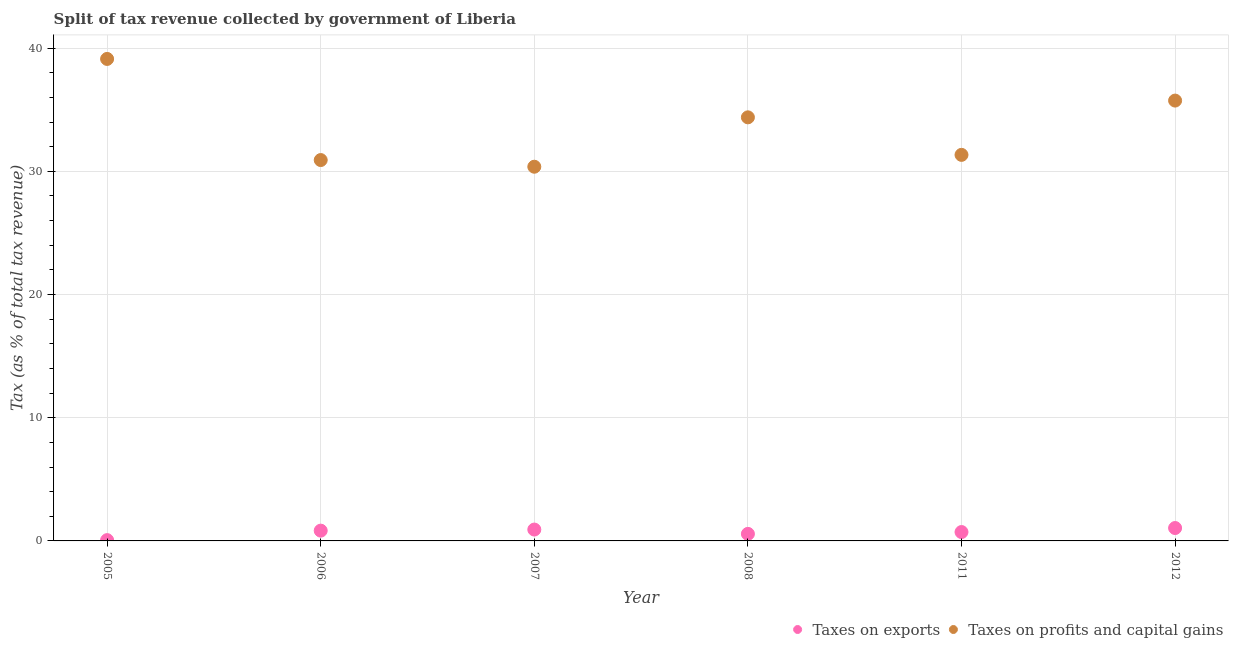What is the percentage of revenue obtained from taxes on exports in 2006?
Offer a terse response. 0.83. Across all years, what is the maximum percentage of revenue obtained from taxes on profits and capital gains?
Your answer should be very brief. 39.13. Across all years, what is the minimum percentage of revenue obtained from taxes on profits and capital gains?
Provide a short and direct response. 30.38. In which year was the percentage of revenue obtained from taxes on exports minimum?
Offer a terse response. 2005. What is the total percentage of revenue obtained from taxes on exports in the graph?
Offer a terse response. 4.16. What is the difference between the percentage of revenue obtained from taxes on profits and capital gains in 2005 and that in 2007?
Ensure brevity in your answer.  8.75. What is the difference between the percentage of revenue obtained from taxes on exports in 2007 and the percentage of revenue obtained from taxes on profits and capital gains in 2012?
Your answer should be compact. -34.82. What is the average percentage of revenue obtained from taxes on profits and capital gains per year?
Give a very brief answer. 33.65. In the year 2006, what is the difference between the percentage of revenue obtained from taxes on exports and percentage of revenue obtained from taxes on profits and capital gains?
Keep it short and to the point. -30.08. In how many years, is the percentage of revenue obtained from taxes on exports greater than 26 %?
Your answer should be compact. 0. What is the ratio of the percentage of revenue obtained from taxes on profits and capital gains in 2008 to that in 2011?
Your answer should be compact. 1.1. Is the percentage of revenue obtained from taxes on profits and capital gains in 2007 less than that in 2011?
Your response must be concise. Yes. Is the difference between the percentage of revenue obtained from taxes on exports in 2008 and 2011 greater than the difference between the percentage of revenue obtained from taxes on profits and capital gains in 2008 and 2011?
Your response must be concise. No. What is the difference between the highest and the second highest percentage of revenue obtained from taxes on profits and capital gains?
Keep it short and to the point. 3.38. What is the difference between the highest and the lowest percentage of revenue obtained from taxes on exports?
Ensure brevity in your answer.  0.98. Is the sum of the percentage of revenue obtained from taxes on exports in 2006 and 2008 greater than the maximum percentage of revenue obtained from taxes on profits and capital gains across all years?
Give a very brief answer. No. Does the percentage of revenue obtained from taxes on profits and capital gains monotonically increase over the years?
Ensure brevity in your answer.  No. Is the percentage of revenue obtained from taxes on profits and capital gains strictly greater than the percentage of revenue obtained from taxes on exports over the years?
Offer a terse response. Yes. What is the difference between two consecutive major ticks on the Y-axis?
Offer a very short reply. 10. Where does the legend appear in the graph?
Ensure brevity in your answer.  Bottom right. What is the title of the graph?
Give a very brief answer. Split of tax revenue collected by government of Liberia. Does "Taxes on exports" appear as one of the legend labels in the graph?
Make the answer very short. Yes. What is the label or title of the Y-axis?
Give a very brief answer. Tax (as % of total tax revenue). What is the Tax (as % of total tax revenue) in Taxes on exports in 2005?
Make the answer very short. 0.06. What is the Tax (as % of total tax revenue) of Taxes on profits and capital gains in 2005?
Your response must be concise. 39.13. What is the Tax (as % of total tax revenue) in Taxes on exports in 2006?
Your answer should be compact. 0.83. What is the Tax (as % of total tax revenue) in Taxes on profits and capital gains in 2006?
Keep it short and to the point. 30.92. What is the Tax (as % of total tax revenue) in Taxes on exports in 2007?
Give a very brief answer. 0.92. What is the Tax (as % of total tax revenue) of Taxes on profits and capital gains in 2007?
Keep it short and to the point. 30.38. What is the Tax (as % of total tax revenue) of Taxes on exports in 2008?
Your answer should be very brief. 0.57. What is the Tax (as % of total tax revenue) of Taxes on profits and capital gains in 2008?
Offer a terse response. 34.38. What is the Tax (as % of total tax revenue) of Taxes on exports in 2011?
Your response must be concise. 0.72. What is the Tax (as % of total tax revenue) in Taxes on profits and capital gains in 2011?
Keep it short and to the point. 31.34. What is the Tax (as % of total tax revenue) in Taxes on exports in 2012?
Provide a short and direct response. 1.05. What is the Tax (as % of total tax revenue) of Taxes on profits and capital gains in 2012?
Your answer should be very brief. 35.74. Across all years, what is the maximum Tax (as % of total tax revenue) of Taxes on exports?
Make the answer very short. 1.05. Across all years, what is the maximum Tax (as % of total tax revenue) in Taxes on profits and capital gains?
Ensure brevity in your answer.  39.13. Across all years, what is the minimum Tax (as % of total tax revenue) of Taxes on exports?
Provide a short and direct response. 0.06. Across all years, what is the minimum Tax (as % of total tax revenue) in Taxes on profits and capital gains?
Your answer should be compact. 30.38. What is the total Tax (as % of total tax revenue) of Taxes on exports in the graph?
Provide a short and direct response. 4.16. What is the total Tax (as % of total tax revenue) of Taxes on profits and capital gains in the graph?
Your response must be concise. 201.89. What is the difference between the Tax (as % of total tax revenue) in Taxes on exports in 2005 and that in 2006?
Make the answer very short. -0.77. What is the difference between the Tax (as % of total tax revenue) of Taxes on profits and capital gains in 2005 and that in 2006?
Provide a succinct answer. 8.21. What is the difference between the Tax (as % of total tax revenue) in Taxes on exports in 2005 and that in 2007?
Provide a succinct answer. -0.86. What is the difference between the Tax (as % of total tax revenue) in Taxes on profits and capital gains in 2005 and that in 2007?
Ensure brevity in your answer.  8.75. What is the difference between the Tax (as % of total tax revenue) of Taxes on exports in 2005 and that in 2008?
Offer a very short reply. -0.51. What is the difference between the Tax (as % of total tax revenue) in Taxes on profits and capital gains in 2005 and that in 2008?
Keep it short and to the point. 4.74. What is the difference between the Tax (as % of total tax revenue) in Taxes on exports in 2005 and that in 2011?
Keep it short and to the point. -0.66. What is the difference between the Tax (as % of total tax revenue) of Taxes on profits and capital gains in 2005 and that in 2011?
Ensure brevity in your answer.  7.79. What is the difference between the Tax (as % of total tax revenue) of Taxes on exports in 2005 and that in 2012?
Offer a very short reply. -0.98. What is the difference between the Tax (as % of total tax revenue) in Taxes on profits and capital gains in 2005 and that in 2012?
Offer a very short reply. 3.38. What is the difference between the Tax (as % of total tax revenue) in Taxes on exports in 2006 and that in 2007?
Your answer should be very brief. -0.09. What is the difference between the Tax (as % of total tax revenue) of Taxes on profits and capital gains in 2006 and that in 2007?
Provide a short and direct response. 0.54. What is the difference between the Tax (as % of total tax revenue) of Taxes on exports in 2006 and that in 2008?
Offer a very short reply. 0.26. What is the difference between the Tax (as % of total tax revenue) of Taxes on profits and capital gains in 2006 and that in 2008?
Your answer should be very brief. -3.47. What is the difference between the Tax (as % of total tax revenue) of Taxes on exports in 2006 and that in 2011?
Keep it short and to the point. 0.11. What is the difference between the Tax (as % of total tax revenue) in Taxes on profits and capital gains in 2006 and that in 2011?
Provide a succinct answer. -0.42. What is the difference between the Tax (as % of total tax revenue) in Taxes on exports in 2006 and that in 2012?
Make the answer very short. -0.21. What is the difference between the Tax (as % of total tax revenue) of Taxes on profits and capital gains in 2006 and that in 2012?
Your response must be concise. -4.83. What is the difference between the Tax (as % of total tax revenue) in Taxes on exports in 2007 and that in 2008?
Make the answer very short. 0.35. What is the difference between the Tax (as % of total tax revenue) in Taxes on profits and capital gains in 2007 and that in 2008?
Your response must be concise. -4.01. What is the difference between the Tax (as % of total tax revenue) in Taxes on exports in 2007 and that in 2011?
Your response must be concise. 0.2. What is the difference between the Tax (as % of total tax revenue) of Taxes on profits and capital gains in 2007 and that in 2011?
Keep it short and to the point. -0.96. What is the difference between the Tax (as % of total tax revenue) of Taxes on exports in 2007 and that in 2012?
Give a very brief answer. -0.12. What is the difference between the Tax (as % of total tax revenue) in Taxes on profits and capital gains in 2007 and that in 2012?
Offer a terse response. -5.37. What is the difference between the Tax (as % of total tax revenue) in Taxes on exports in 2008 and that in 2011?
Ensure brevity in your answer.  -0.15. What is the difference between the Tax (as % of total tax revenue) in Taxes on profits and capital gains in 2008 and that in 2011?
Provide a succinct answer. 3.05. What is the difference between the Tax (as % of total tax revenue) of Taxes on exports in 2008 and that in 2012?
Offer a terse response. -0.47. What is the difference between the Tax (as % of total tax revenue) of Taxes on profits and capital gains in 2008 and that in 2012?
Offer a very short reply. -1.36. What is the difference between the Tax (as % of total tax revenue) of Taxes on exports in 2011 and that in 2012?
Offer a terse response. -0.33. What is the difference between the Tax (as % of total tax revenue) of Taxes on profits and capital gains in 2011 and that in 2012?
Make the answer very short. -4.41. What is the difference between the Tax (as % of total tax revenue) of Taxes on exports in 2005 and the Tax (as % of total tax revenue) of Taxes on profits and capital gains in 2006?
Ensure brevity in your answer.  -30.85. What is the difference between the Tax (as % of total tax revenue) of Taxes on exports in 2005 and the Tax (as % of total tax revenue) of Taxes on profits and capital gains in 2007?
Offer a very short reply. -30.31. What is the difference between the Tax (as % of total tax revenue) of Taxes on exports in 2005 and the Tax (as % of total tax revenue) of Taxes on profits and capital gains in 2008?
Provide a succinct answer. -34.32. What is the difference between the Tax (as % of total tax revenue) in Taxes on exports in 2005 and the Tax (as % of total tax revenue) in Taxes on profits and capital gains in 2011?
Your answer should be very brief. -31.27. What is the difference between the Tax (as % of total tax revenue) in Taxes on exports in 2005 and the Tax (as % of total tax revenue) in Taxes on profits and capital gains in 2012?
Your response must be concise. -35.68. What is the difference between the Tax (as % of total tax revenue) of Taxes on exports in 2006 and the Tax (as % of total tax revenue) of Taxes on profits and capital gains in 2007?
Provide a short and direct response. -29.54. What is the difference between the Tax (as % of total tax revenue) in Taxes on exports in 2006 and the Tax (as % of total tax revenue) in Taxes on profits and capital gains in 2008?
Your answer should be very brief. -33.55. What is the difference between the Tax (as % of total tax revenue) of Taxes on exports in 2006 and the Tax (as % of total tax revenue) of Taxes on profits and capital gains in 2011?
Keep it short and to the point. -30.5. What is the difference between the Tax (as % of total tax revenue) in Taxes on exports in 2006 and the Tax (as % of total tax revenue) in Taxes on profits and capital gains in 2012?
Offer a very short reply. -34.91. What is the difference between the Tax (as % of total tax revenue) in Taxes on exports in 2007 and the Tax (as % of total tax revenue) in Taxes on profits and capital gains in 2008?
Provide a succinct answer. -33.46. What is the difference between the Tax (as % of total tax revenue) in Taxes on exports in 2007 and the Tax (as % of total tax revenue) in Taxes on profits and capital gains in 2011?
Your answer should be very brief. -30.42. What is the difference between the Tax (as % of total tax revenue) in Taxes on exports in 2007 and the Tax (as % of total tax revenue) in Taxes on profits and capital gains in 2012?
Offer a terse response. -34.82. What is the difference between the Tax (as % of total tax revenue) of Taxes on exports in 2008 and the Tax (as % of total tax revenue) of Taxes on profits and capital gains in 2011?
Give a very brief answer. -30.77. What is the difference between the Tax (as % of total tax revenue) in Taxes on exports in 2008 and the Tax (as % of total tax revenue) in Taxes on profits and capital gains in 2012?
Your answer should be very brief. -35.17. What is the difference between the Tax (as % of total tax revenue) of Taxes on exports in 2011 and the Tax (as % of total tax revenue) of Taxes on profits and capital gains in 2012?
Offer a terse response. -35.02. What is the average Tax (as % of total tax revenue) in Taxes on exports per year?
Provide a short and direct response. 0.69. What is the average Tax (as % of total tax revenue) in Taxes on profits and capital gains per year?
Your answer should be compact. 33.65. In the year 2005, what is the difference between the Tax (as % of total tax revenue) of Taxes on exports and Tax (as % of total tax revenue) of Taxes on profits and capital gains?
Keep it short and to the point. -39.06. In the year 2006, what is the difference between the Tax (as % of total tax revenue) in Taxes on exports and Tax (as % of total tax revenue) in Taxes on profits and capital gains?
Offer a terse response. -30.08. In the year 2007, what is the difference between the Tax (as % of total tax revenue) of Taxes on exports and Tax (as % of total tax revenue) of Taxes on profits and capital gains?
Make the answer very short. -29.45. In the year 2008, what is the difference between the Tax (as % of total tax revenue) of Taxes on exports and Tax (as % of total tax revenue) of Taxes on profits and capital gains?
Your answer should be compact. -33.81. In the year 2011, what is the difference between the Tax (as % of total tax revenue) in Taxes on exports and Tax (as % of total tax revenue) in Taxes on profits and capital gains?
Your answer should be compact. -30.62. In the year 2012, what is the difference between the Tax (as % of total tax revenue) in Taxes on exports and Tax (as % of total tax revenue) in Taxes on profits and capital gains?
Give a very brief answer. -34.7. What is the ratio of the Tax (as % of total tax revenue) in Taxes on exports in 2005 to that in 2006?
Offer a very short reply. 0.08. What is the ratio of the Tax (as % of total tax revenue) of Taxes on profits and capital gains in 2005 to that in 2006?
Offer a very short reply. 1.27. What is the ratio of the Tax (as % of total tax revenue) of Taxes on exports in 2005 to that in 2007?
Provide a succinct answer. 0.07. What is the ratio of the Tax (as % of total tax revenue) in Taxes on profits and capital gains in 2005 to that in 2007?
Offer a terse response. 1.29. What is the ratio of the Tax (as % of total tax revenue) of Taxes on exports in 2005 to that in 2008?
Offer a very short reply. 0.11. What is the ratio of the Tax (as % of total tax revenue) of Taxes on profits and capital gains in 2005 to that in 2008?
Make the answer very short. 1.14. What is the ratio of the Tax (as % of total tax revenue) in Taxes on exports in 2005 to that in 2011?
Your response must be concise. 0.09. What is the ratio of the Tax (as % of total tax revenue) of Taxes on profits and capital gains in 2005 to that in 2011?
Make the answer very short. 1.25. What is the ratio of the Tax (as % of total tax revenue) of Taxes on exports in 2005 to that in 2012?
Offer a very short reply. 0.06. What is the ratio of the Tax (as % of total tax revenue) of Taxes on profits and capital gains in 2005 to that in 2012?
Your answer should be very brief. 1.09. What is the ratio of the Tax (as % of total tax revenue) in Taxes on exports in 2006 to that in 2007?
Offer a terse response. 0.9. What is the ratio of the Tax (as % of total tax revenue) in Taxes on profits and capital gains in 2006 to that in 2007?
Your answer should be compact. 1.02. What is the ratio of the Tax (as % of total tax revenue) in Taxes on exports in 2006 to that in 2008?
Make the answer very short. 1.46. What is the ratio of the Tax (as % of total tax revenue) in Taxes on profits and capital gains in 2006 to that in 2008?
Keep it short and to the point. 0.9. What is the ratio of the Tax (as % of total tax revenue) in Taxes on exports in 2006 to that in 2011?
Keep it short and to the point. 1.16. What is the ratio of the Tax (as % of total tax revenue) in Taxes on profits and capital gains in 2006 to that in 2011?
Your answer should be compact. 0.99. What is the ratio of the Tax (as % of total tax revenue) of Taxes on exports in 2006 to that in 2012?
Your answer should be compact. 0.8. What is the ratio of the Tax (as % of total tax revenue) in Taxes on profits and capital gains in 2006 to that in 2012?
Your answer should be very brief. 0.86. What is the ratio of the Tax (as % of total tax revenue) in Taxes on exports in 2007 to that in 2008?
Give a very brief answer. 1.61. What is the ratio of the Tax (as % of total tax revenue) in Taxes on profits and capital gains in 2007 to that in 2008?
Provide a short and direct response. 0.88. What is the ratio of the Tax (as % of total tax revenue) of Taxes on exports in 2007 to that in 2011?
Your answer should be compact. 1.28. What is the ratio of the Tax (as % of total tax revenue) in Taxes on profits and capital gains in 2007 to that in 2011?
Your answer should be very brief. 0.97. What is the ratio of the Tax (as % of total tax revenue) of Taxes on exports in 2007 to that in 2012?
Your answer should be very brief. 0.88. What is the ratio of the Tax (as % of total tax revenue) of Taxes on profits and capital gains in 2007 to that in 2012?
Keep it short and to the point. 0.85. What is the ratio of the Tax (as % of total tax revenue) of Taxes on exports in 2008 to that in 2011?
Provide a succinct answer. 0.79. What is the ratio of the Tax (as % of total tax revenue) of Taxes on profits and capital gains in 2008 to that in 2011?
Your answer should be compact. 1.1. What is the ratio of the Tax (as % of total tax revenue) in Taxes on exports in 2008 to that in 2012?
Your answer should be very brief. 0.55. What is the ratio of the Tax (as % of total tax revenue) of Taxes on exports in 2011 to that in 2012?
Keep it short and to the point. 0.69. What is the ratio of the Tax (as % of total tax revenue) in Taxes on profits and capital gains in 2011 to that in 2012?
Give a very brief answer. 0.88. What is the difference between the highest and the second highest Tax (as % of total tax revenue) in Taxes on exports?
Provide a short and direct response. 0.12. What is the difference between the highest and the second highest Tax (as % of total tax revenue) of Taxes on profits and capital gains?
Offer a terse response. 3.38. What is the difference between the highest and the lowest Tax (as % of total tax revenue) of Taxes on exports?
Offer a terse response. 0.98. What is the difference between the highest and the lowest Tax (as % of total tax revenue) of Taxes on profits and capital gains?
Ensure brevity in your answer.  8.75. 